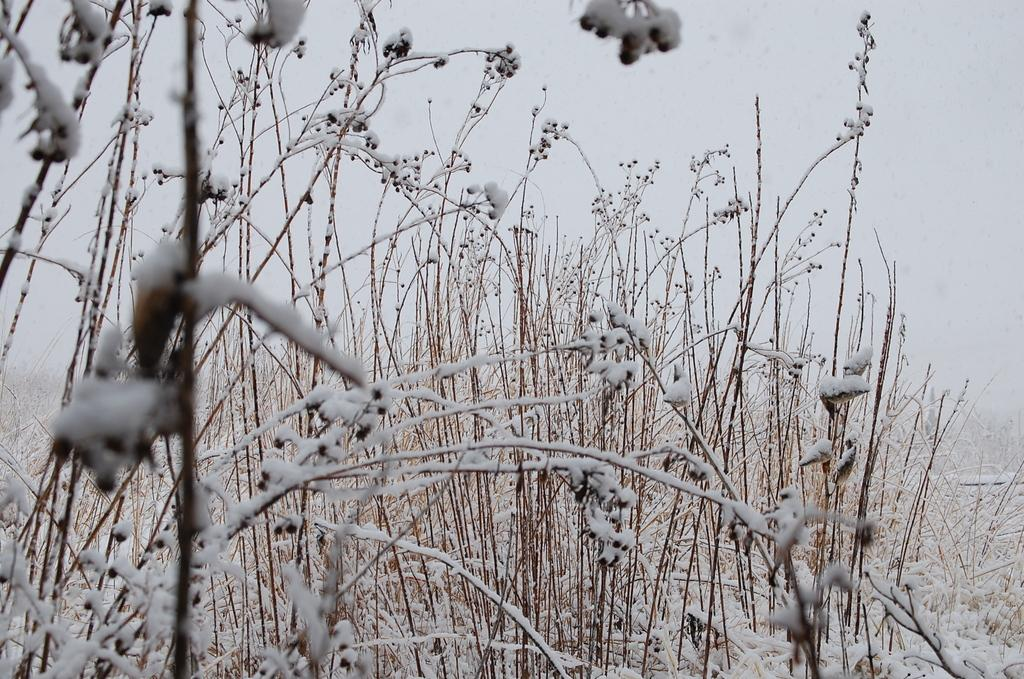What type of living organisms can be seen in the image? Plants can be seen in the image. How are the plants in the image affected by the weather? The plants are covered with snow in the image. What can be seen in the background of the image? Sky is visible in the background of the image. What arithmetic problem is the son solving in the image? There is no son or arithmetic problem present in the image. What type of house can be seen in the background of the image? There is no house visible in the background of the image; only the sky is present. 